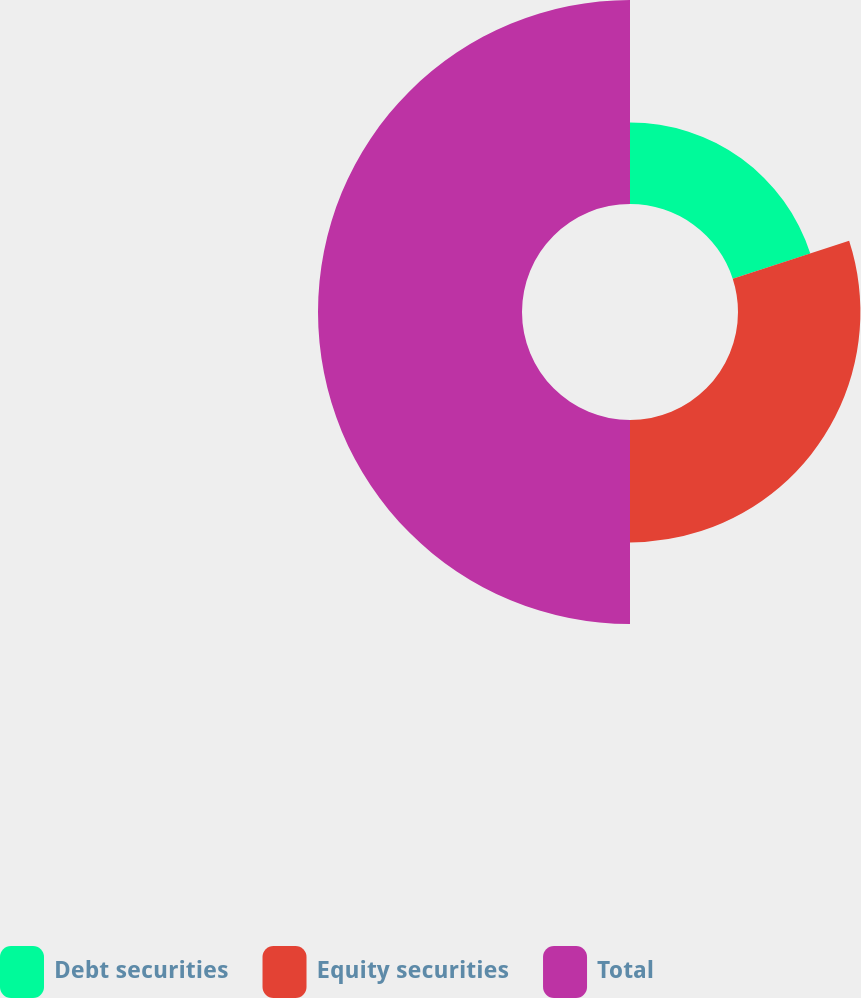<chart> <loc_0><loc_0><loc_500><loc_500><pie_chart><fcel>Debt securities<fcel>Equity securities<fcel>Total<nl><fcel>20.0%<fcel>30.0%<fcel>50.0%<nl></chart> 